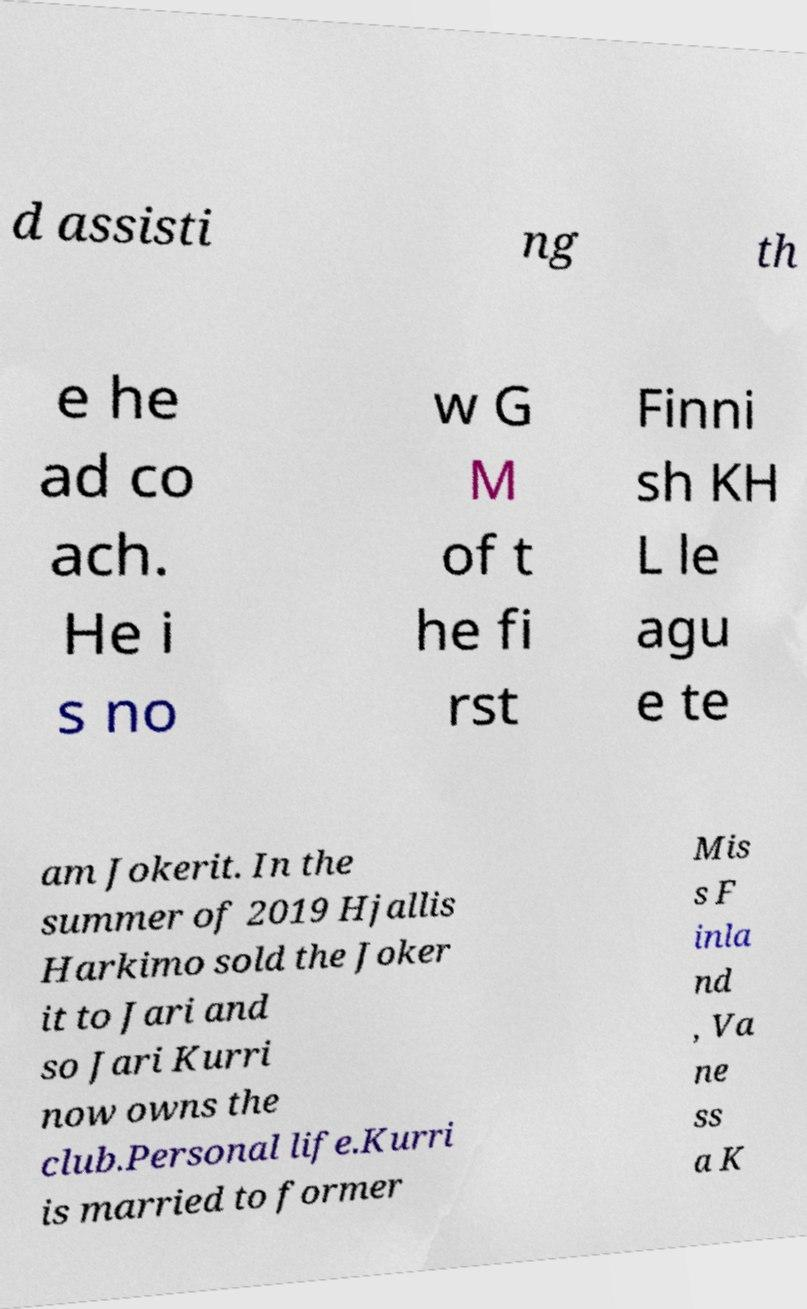Can you accurately transcribe the text from the provided image for me? d assisti ng th e he ad co ach. He i s no w G M of t he fi rst Finni sh KH L le agu e te am Jokerit. In the summer of 2019 Hjallis Harkimo sold the Joker it to Jari and so Jari Kurri now owns the club.Personal life.Kurri is married to former Mis s F inla nd , Va ne ss a K 